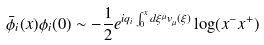Convert formula to latex. <formula><loc_0><loc_0><loc_500><loc_500>\bar { \phi } _ { i } ( x ) \phi _ { i } ( 0 ) \sim - \frac { 1 } { 2 } e ^ { i q _ { i } \int _ { 0 } ^ { x } d \xi ^ { \mu } v _ { \mu } ( \xi ) } \log ( x ^ { - } x ^ { + } )</formula> 